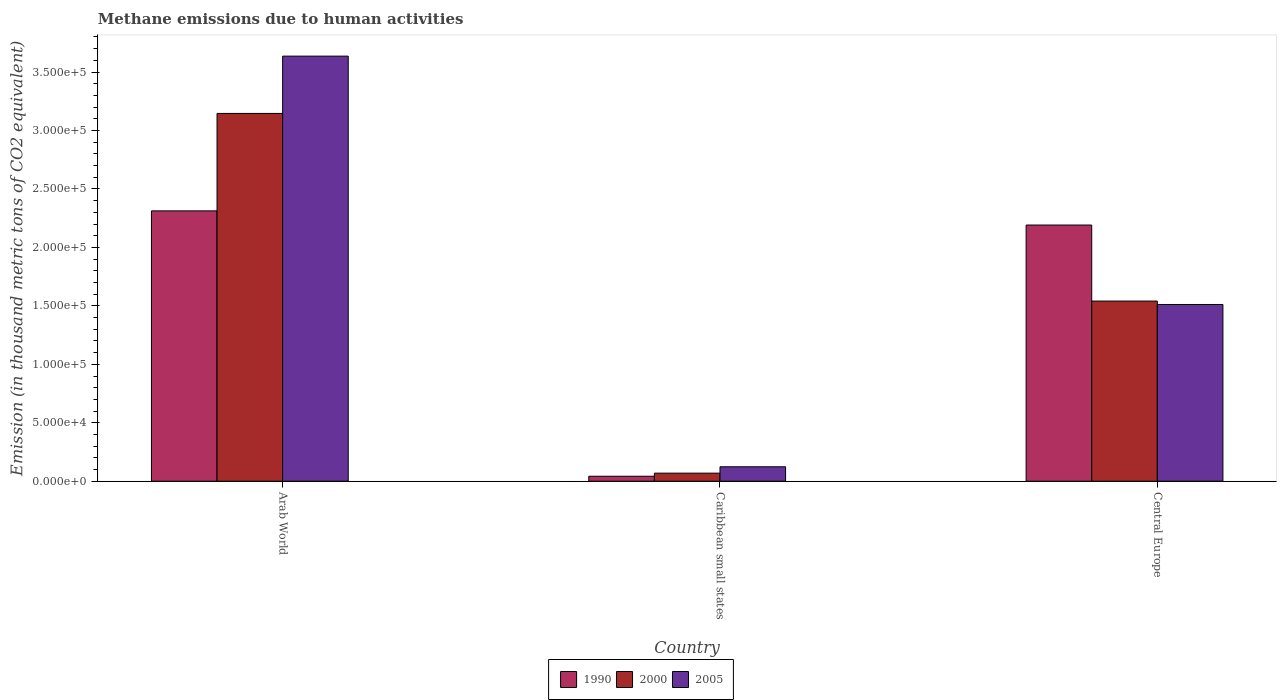How many different coloured bars are there?
Give a very brief answer. 3. How many groups of bars are there?
Ensure brevity in your answer.  3. Are the number of bars per tick equal to the number of legend labels?
Your answer should be compact. Yes. Are the number of bars on each tick of the X-axis equal?
Give a very brief answer. Yes. How many bars are there on the 1st tick from the left?
Your answer should be compact. 3. What is the label of the 1st group of bars from the left?
Give a very brief answer. Arab World. What is the amount of methane emitted in 2000 in Caribbean small states?
Offer a terse response. 6906.7. Across all countries, what is the maximum amount of methane emitted in 2000?
Your response must be concise. 3.15e+05. Across all countries, what is the minimum amount of methane emitted in 2000?
Make the answer very short. 6906.7. In which country was the amount of methane emitted in 1990 maximum?
Make the answer very short. Arab World. In which country was the amount of methane emitted in 2000 minimum?
Offer a terse response. Caribbean small states. What is the total amount of methane emitted in 2000 in the graph?
Give a very brief answer. 4.76e+05. What is the difference between the amount of methane emitted in 1990 in Caribbean small states and that in Central Europe?
Provide a succinct answer. -2.15e+05. What is the difference between the amount of methane emitted in 1990 in Central Europe and the amount of methane emitted in 2005 in Caribbean small states?
Offer a very short reply. 2.07e+05. What is the average amount of methane emitted in 1990 per country?
Your answer should be very brief. 1.52e+05. What is the difference between the amount of methane emitted of/in 1990 and amount of methane emitted of/in 2000 in Central Europe?
Your answer should be compact. 6.50e+04. In how many countries, is the amount of methane emitted in 1990 greater than 290000 thousand metric tons?
Ensure brevity in your answer.  0. What is the ratio of the amount of methane emitted in 2005 in Caribbean small states to that in Central Europe?
Your answer should be very brief. 0.08. Is the amount of methane emitted in 1990 in Arab World less than that in Caribbean small states?
Keep it short and to the point. No. What is the difference between the highest and the second highest amount of methane emitted in 2005?
Your answer should be very brief. -3.51e+05. What is the difference between the highest and the lowest amount of methane emitted in 1990?
Provide a succinct answer. 2.27e+05. How many bars are there?
Your answer should be compact. 9. Are all the bars in the graph horizontal?
Ensure brevity in your answer.  No. Are the values on the major ticks of Y-axis written in scientific E-notation?
Ensure brevity in your answer.  Yes. Does the graph contain any zero values?
Keep it short and to the point. No. Does the graph contain grids?
Make the answer very short. No. Where does the legend appear in the graph?
Make the answer very short. Bottom center. What is the title of the graph?
Your response must be concise. Methane emissions due to human activities. What is the label or title of the X-axis?
Your answer should be compact. Country. What is the label or title of the Y-axis?
Offer a very short reply. Emission (in thousand metric tons of CO2 equivalent). What is the Emission (in thousand metric tons of CO2 equivalent) in 1990 in Arab World?
Make the answer very short. 2.31e+05. What is the Emission (in thousand metric tons of CO2 equivalent) in 2000 in Arab World?
Ensure brevity in your answer.  3.15e+05. What is the Emission (in thousand metric tons of CO2 equivalent) in 2005 in Arab World?
Provide a succinct answer. 3.64e+05. What is the Emission (in thousand metric tons of CO2 equivalent) in 1990 in Caribbean small states?
Offer a very short reply. 4272.7. What is the Emission (in thousand metric tons of CO2 equivalent) in 2000 in Caribbean small states?
Give a very brief answer. 6906.7. What is the Emission (in thousand metric tons of CO2 equivalent) in 2005 in Caribbean small states?
Offer a very short reply. 1.24e+04. What is the Emission (in thousand metric tons of CO2 equivalent) of 1990 in Central Europe?
Provide a succinct answer. 2.19e+05. What is the Emission (in thousand metric tons of CO2 equivalent) in 2000 in Central Europe?
Your response must be concise. 1.54e+05. What is the Emission (in thousand metric tons of CO2 equivalent) in 2005 in Central Europe?
Provide a succinct answer. 1.51e+05. Across all countries, what is the maximum Emission (in thousand metric tons of CO2 equivalent) of 1990?
Keep it short and to the point. 2.31e+05. Across all countries, what is the maximum Emission (in thousand metric tons of CO2 equivalent) in 2000?
Ensure brevity in your answer.  3.15e+05. Across all countries, what is the maximum Emission (in thousand metric tons of CO2 equivalent) in 2005?
Provide a succinct answer. 3.64e+05. Across all countries, what is the minimum Emission (in thousand metric tons of CO2 equivalent) in 1990?
Make the answer very short. 4272.7. Across all countries, what is the minimum Emission (in thousand metric tons of CO2 equivalent) of 2000?
Offer a very short reply. 6906.7. Across all countries, what is the minimum Emission (in thousand metric tons of CO2 equivalent) in 2005?
Your response must be concise. 1.24e+04. What is the total Emission (in thousand metric tons of CO2 equivalent) of 1990 in the graph?
Provide a short and direct response. 4.55e+05. What is the total Emission (in thousand metric tons of CO2 equivalent) in 2000 in the graph?
Your answer should be compact. 4.76e+05. What is the total Emission (in thousand metric tons of CO2 equivalent) of 2005 in the graph?
Make the answer very short. 5.27e+05. What is the difference between the Emission (in thousand metric tons of CO2 equivalent) in 1990 in Arab World and that in Caribbean small states?
Keep it short and to the point. 2.27e+05. What is the difference between the Emission (in thousand metric tons of CO2 equivalent) in 2000 in Arab World and that in Caribbean small states?
Provide a short and direct response. 3.08e+05. What is the difference between the Emission (in thousand metric tons of CO2 equivalent) of 2005 in Arab World and that in Caribbean small states?
Your answer should be compact. 3.51e+05. What is the difference between the Emission (in thousand metric tons of CO2 equivalent) of 1990 in Arab World and that in Central Europe?
Ensure brevity in your answer.  1.21e+04. What is the difference between the Emission (in thousand metric tons of CO2 equivalent) of 2000 in Arab World and that in Central Europe?
Your answer should be compact. 1.60e+05. What is the difference between the Emission (in thousand metric tons of CO2 equivalent) of 2005 in Arab World and that in Central Europe?
Give a very brief answer. 2.12e+05. What is the difference between the Emission (in thousand metric tons of CO2 equivalent) in 1990 in Caribbean small states and that in Central Europe?
Offer a terse response. -2.15e+05. What is the difference between the Emission (in thousand metric tons of CO2 equivalent) in 2000 in Caribbean small states and that in Central Europe?
Offer a terse response. -1.47e+05. What is the difference between the Emission (in thousand metric tons of CO2 equivalent) in 2005 in Caribbean small states and that in Central Europe?
Make the answer very short. -1.39e+05. What is the difference between the Emission (in thousand metric tons of CO2 equivalent) in 1990 in Arab World and the Emission (in thousand metric tons of CO2 equivalent) in 2000 in Caribbean small states?
Offer a very short reply. 2.24e+05. What is the difference between the Emission (in thousand metric tons of CO2 equivalent) in 1990 in Arab World and the Emission (in thousand metric tons of CO2 equivalent) in 2005 in Caribbean small states?
Your response must be concise. 2.19e+05. What is the difference between the Emission (in thousand metric tons of CO2 equivalent) in 2000 in Arab World and the Emission (in thousand metric tons of CO2 equivalent) in 2005 in Caribbean small states?
Give a very brief answer. 3.02e+05. What is the difference between the Emission (in thousand metric tons of CO2 equivalent) in 1990 in Arab World and the Emission (in thousand metric tons of CO2 equivalent) in 2000 in Central Europe?
Offer a terse response. 7.71e+04. What is the difference between the Emission (in thousand metric tons of CO2 equivalent) of 1990 in Arab World and the Emission (in thousand metric tons of CO2 equivalent) of 2005 in Central Europe?
Provide a succinct answer. 8.01e+04. What is the difference between the Emission (in thousand metric tons of CO2 equivalent) of 2000 in Arab World and the Emission (in thousand metric tons of CO2 equivalent) of 2005 in Central Europe?
Make the answer very short. 1.63e+05. What is the difference between the Emission (in thousand metric tons of CO2 equivalent) of 1990 in Caribbean small states and the Emission (in thousand metric tons of CO2 equivalent) of 2000 in Central Europe?
Your response must be concise. -1.50e+05. What is the difference between the Emission (in thousand metric tons of CO2 equivalent) of 1990 in Caribbean small states and the Emission (in thousand metric tons of CO2 equivalent) of 2005 in Central Europe?
Offer a very short reply. -1.47e+05. What is the difference between the Emission (in thousand metric tons of CO2 equivalent) in 2000 in Caribbean small states and the Emission (in thousand metric tons of CO2 equivalent) in 2005 in Central Europe?
Provide a succinct answer. -1.44e+05. What is the average Emission (in thousand metric tons of CO2 equivalent) of 1990 per country?
Ensure brevity in your answer.  1.52e+05. What is the average Emission (in thousand metric tons of CO2 equivalent) in 2000 per country?
Provide a short and direct response. 1.59e+05. What is the average Emission (in thousand metric tons of CO2 equivalent) in 2005 per country?
Keep it short and to the point. 1.76e+05. What is the difference between the Emission (in thousand metric tons of CO2 equivalent) of 1990 and Emission (in thousand metric tons of CO2 equivalent) of 2000 in Arab World?
Your answer should be compact. -8.33e+04. What is the difference between the Emission (in thousand metric tons of CO2 equivalent) of 1990 and Emission (in thousand metric tons of CO2 equivalent) of 2005 in Arab World?
Make the answer very short. -1.32e+05. What is the difference between the Emission (in thousand metric tons of CO2 equivalent) in 2000 and Emission (in thousand metric tons of CO2 equivalent) in 2005 in Arab World?
Provide a short and direct response. -4.90e+04. What is the difference between the Emission (in thousand metric tons of CO2 equivalent) of 1990 and Emission (in thousand metric tons of CO2 equivalent) of 2000 in Caribbean small states?
Give a very brief answer. -2634. What is the difference between the Emission (in thousand metric tons of CO2 equivalent) in 1990 and Emission (in thousand metric tons of CO2 equivalent) in 2005 in Caribbean small states?
Your answer should be very brief. -8088.5. What is the difference between the Emission (in thousand metric tons of CO2 equivalent) of 2000 and Emission (in thousand metric tons of CO2 equivalent) of 2005 in Caribbean small states?
Offer a very short reply. -5454.5. What is the difference between the Emission (in thousand metric tons of CO2 equivalent) in 1990 and Emission (in thousand metric tons of CO2 equivalent) in 2000 in Central Europe?
Your answer should be very brief. 6.50e+04. What is the difference between the Emission (in thousand metric tons of CO2 equivalent) of 1990 and Emission (in thousand metric tons of CO2 equivalent) of 2005 in Central Europe?
Your answer should be very brief. 6.80e+04. What is the difference between the Emission (in thousand metric tons of CO2 equivalent) of 2000 and Emission (in thousand metric tons of CO2 equivalent) of 2005 in Central Europe?
Give a very brief answer. 2935.3. What is the ratio of the Emission (in thousand metric tons of CO2 equivalent) in 1990 in Arab World to that in Caribbean small states?
Ensure brevity in your answer.  54.12. What is the ratio of the Emission (in thousand metric tons of CO2 equivalent) in 2000 in Arab World to that in Caribbean small states?
Offer a terse response. 45.55. What is the ratio of the Emission (in thousand metric tons of CO2 equivalent) in 2005 in Arab World to that in Caribbean small states?
Your answer should be very brief. 29.41. What is the ratio of the Emission (in thousand metric tons of CO2 equivalent) in 1990 in Arab World to that in Central Europe?
Your answer should be compact. 1.06. What is the ratio of the Emission (in thousand metric tons of CO2 equivalent) of 2000 in Arab World to that in Central Europe?
Provide a short and direct response. 2.04. What is the ratio of the Emission (in thousand metric tons of CO2 equivalent) in 2005 in Arab World to that in Central Europe?
Give a very brief answer. 2.41. What is the ratio of the Emission (in thousand metric tons of CO2 equivalent) in 1990 in Caribbean small states to that in Central Europe?
Offer a terse response. 0.02. What is the ratio of the Emission (in thousand metric tons of CO2 equivalent) in 2000 in Caribbean small states to that in Central Europe?
Provide a succinct answer. 0.04. What is the ratio of the Emission (in thousand metric tons of CO2 equivalent) in 2005 in Caribbean small states to that in Central Europe?
Offer a very short reply. 0.08. What is the difference between the highest and the second highest Emission (in thousand metric tons of CO2 equivalent) of 1990?
Ensure brevity in your answer.  1.21e+04. What is the difference between the highest and the second highest Emission (in thousand metric tons of CO2 equivalent) in 2000?
Ensure brevity in your answer.  1.60e+05. What is the difference between the highest and the second highest Emission (in thousand metric tons of CO2 equivalent) in 2005?
Ensure brevity in your answer.  2.12e+05. What is the difference between the highest and the lowest Emission (in thousand metric tons of CO2 equivalent) of 1990?
Provide a succinct answer. 2.27e+05. What is the difference between the highest and the lowest Emission (in thousand metric tons of CO2 equivalent) of 2000?
Make the answer very short. 3.08e+05. What is the difference between the highest and the lowest Emission (in thousand metric tons of CO2 equivalent) in 2005?
Make the answer very short. 3.51e+05. 